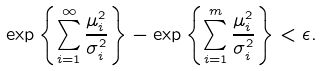Convert formula to latex. <formula><loc_0><loc_0><loc_500><loc_500>\exp \left \{ \sum _ { i = 1 } ^ { \infty } \frac { \mu _ { i } ^ { 2 } } { \sigma _ { i } ^ { 2 } } \right \} - \exp \left \{ \sum _ { i = 1 } ^ { m } \frac { \mu _ { i } ^ { 2 } } { \sigma _ { i } ^ { 2 } } \right \} < \epsilon .</formula> 